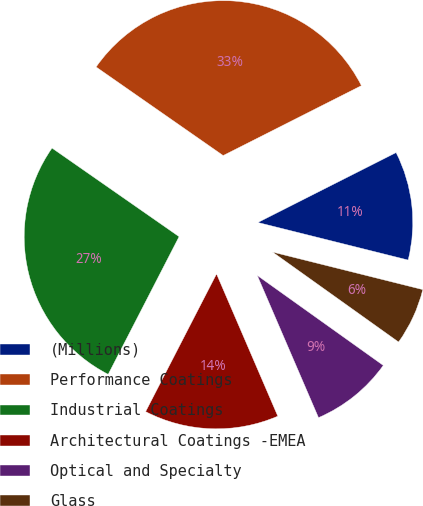Convert chart. <chart><loc_0><loc_0><loc_500><loc_500><pie_chart><fcel>(Millions)<fcel>Performance Coatings<fcel>Industrial Coatings<fcel>Architectural Coatings -EMEA<fcel>Optical and Specialty<fcel>Glass<nl><fcel>11.35%<fcel>32.86%<fcel>27.12%<fcel>14.04%<fcel>8.66%<fcel>5.97%<nl></chart> 